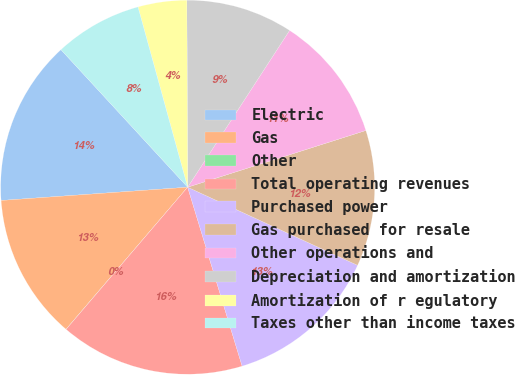<chart> <loc_0><loc_0><loc_500><loc_500><pie_chart><fcel>Electric<fcel>Gas<fcel>Other<fcel>Total operating revenues<fcel>Purchased power<fcel>Gas purchased for resale<fcel>Other operations and<fcel>Depreciation and amortization<fcel>Amortization of r egulatory<fcel>Taxes other than income taxes<nl><fcel>14.28%<fcel>12.6%<fcel>0.01%<fcel>15.96%<fcel>13.44%<fcel>11.76%<fcel>10.92%<fcel>9.24%<fcel>4.21%<fcel>7.57%<nl></chart> 